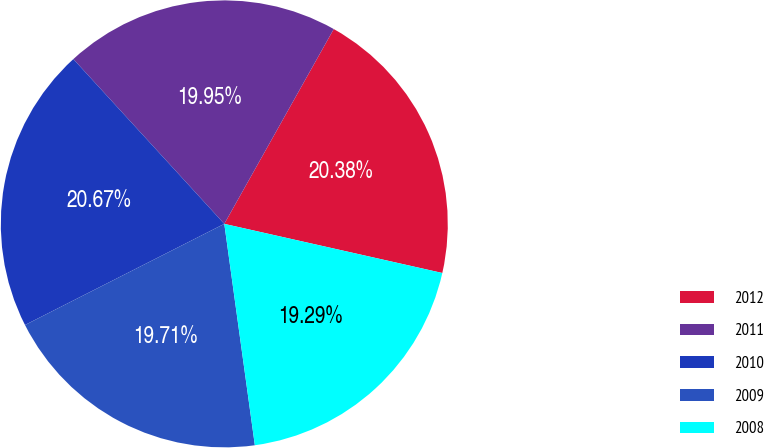<chart> <loc_0><loc_0><loc_500><loc_500><pie_chart><fcel>2012<fcel>2011<fcel>2010<fcel>2009<fcel>2008<nl><fcel>20.38%<fcel>19.95%<fcel>20.67%<fcel>19.71%<fcel>19.29%<nl></chart> 